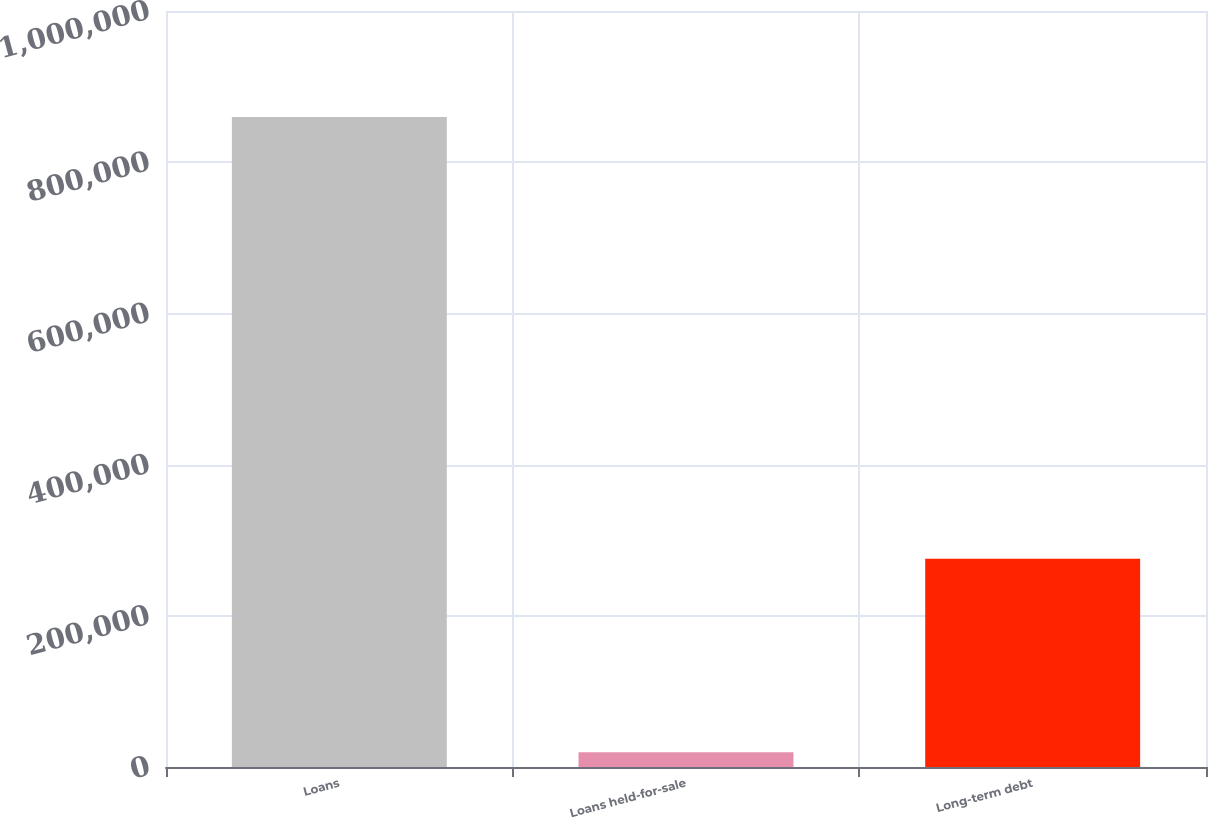<chart> <loc_0><loc_0><loc_500><loc_500><bar_chart><fcel>Loans<fcel>Loans held-for-sale<fcel>Long-term debt<nl><fcel>859875<fcel>19413<fcel>275585<nl></chart> 